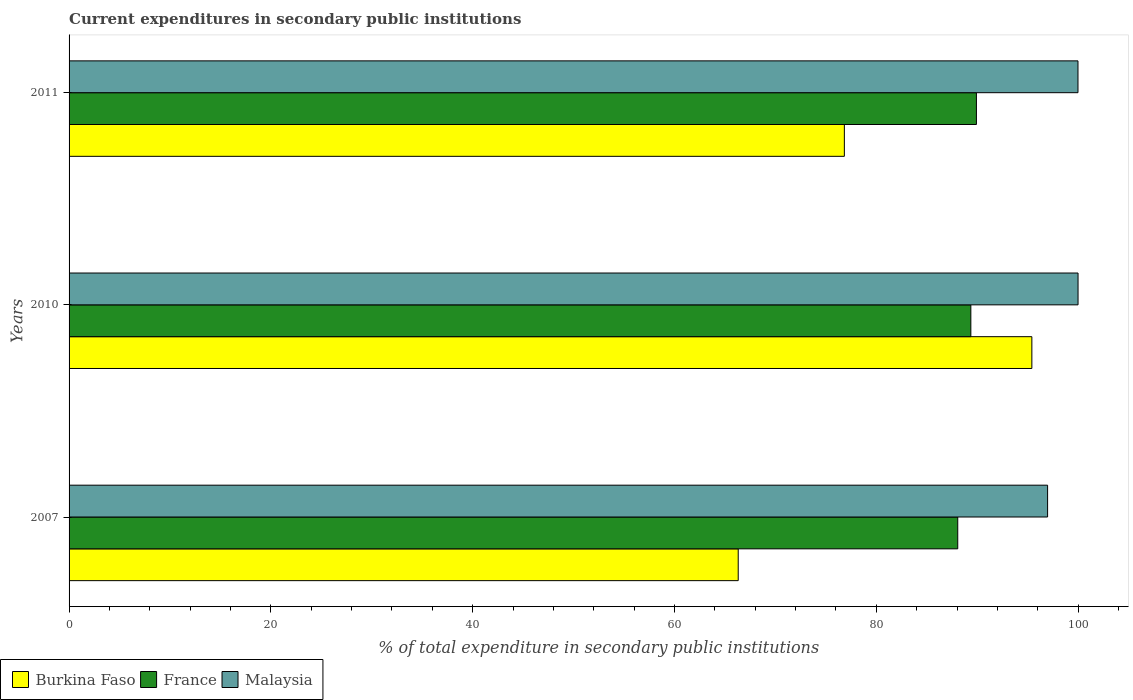How many different coloured bars are there?
Provide a succinct answer. 3. How many groups of bars are there?
Give a very brief answer. 3. What is the current expenditures in secondary public institutions in Burkina Faso in 2007?
Offer a terse response. 66.31. Across all years, what is the maximum current expenditures in secondary public institutions in Malaysia?
Provide a succinct answer. 99.99. Across all years, what is the minimum current expenditures in secondary public institutions in Malaysia?
Give a very brief answer. 96.97. What is the total current expenditures in secondary public institutions in France in the graph?
Your answer should be very brief. 267.35. What is the difference between the current expenditures in secondary public institutions in Malaysia in 2007 and that in 2011?
Offer a terse response. -3.01. What is the difference between the current expenditures in secondary public institutions in Burkina Faso in 2011 and the current expenditures in secondary public institutions in France in 2007?
Make the answer very short. -11.24. What is the average current expenditures in secondary public institutions in Burkina Faso per year?
Keep it short and to the point. 79.52. In the year 2007, what is the difference between the current expenditures in secondary public institutions in Malaysia and current expenditures in secondary public institutions in France?
Offer a very short reply. 8.9. In how many years, is the current expenditures in secondary public institutions in Burkina Faso greater than 76 %?
Give a very brief answer. 2. What is the ratio of the current expenditures in secondary public institutions in France in 2010 to that in 2011?
Offer a terse response. 0.99. Is the current expenditures in secondary public institutions in Malaysia in 2007 less than that in 2011?
Your response must be concise. Yes. What is the difference between the highest and the second highest current expenditures in secondary public institutions in France?
Provide a short and direct response. 0.55. What is the difference between the highest and the lowest current expenditures in secondary public institutions in Burkina Faso?
Provide a succinct answer. 29.1. In how many years, is the current expenditures in secondary public institutions in Burkina Faso greater than the average current expenditures in secondary public institutions in Burkina Faso taken over all years?
Your response must be concise. 1. Is the sum of the current expenditures in secondary public institutions in Malaysia in 2007 and 2010 greater than the maximum current expenditures in secondary public institutions in Burkina Faso across all years?
Your response must be concise. Yes. What does the 3rd bar from the top in 2010 represents?
Ensure brevity in your answer.  Burkina Faso. What does the 2nd bar from the bottom in 2011 represents?
Offer a very short reply. France. Are all the bars in the graph horizontal?
Make the answer very short. Yes. What is the difference between two consecutive major ticks on the X-axis?
Make the answer very short. 20. Are the values on the major ticks of X-axis written in scientific E-notation?
Your answer should be compact. No. Does the graph contain grids?
Provide a short and direct response. No. Where does the legend appear in the graph?
Your answer should be very brief. Bottom left. What is the title of the graph?
Your answer should be compact. Current expenditures in secondary public institutions. What is the label or title of the X-axis?
Give a very brief answer. % of total expenditure in secondary public institutions. What is the label or title of the Y-axis?
Your response must be concise. Years. What is the % of total expenditure in secondary public institutions of Burkina Faso in 2007?
Give a very brief answer. 66.31. What is the % of total expenditure in secondary public institutions of France in 2007?
Offer a terse response. 88.07. What is the % of total expenditure in secondary public institutions in Malaysia in 2007?
Ensure brevity in your answer.  96.97. What is the % of total expenditure in secondary public institutions of Burkina Faso in 2010?
Your answer should be compact. 95.41. What is the % of total expenditure in secondary public institutions of France in 2010?
Your answer should be compact. 89.36. What is the % of total expenditure in secondary public institutions of Malaysia in 2010?
Give a very brief answer. 99.99. What is the % of total expenditure in secondary public institutions in Burkina Faso in 2011?
Ensure brevity in your answer.  76.83. What is the % of total expenditure in secondary public institutions in France in 2011?
Provide a short and direct response. 89.92. What is the % of total expenditure in secondary public institutions of Malaysia in 2011?
Provide a succinct answer. 99.98. Across all years, what is the maximum % of total expenditure in secondary public institutions in Burkina Faso?
Ensure brevity in your answer.  95.41. Across all years, what is the maximum % of total expenditure in secondary public institutions of France?
Make the answer very short. 89.92. Across all years, what is the maximum % of total expenditure in secondary public institutions in Malaysia?
Offer a very short reply. 99.99. Across all years, what is the minimum % of total expenditure in secondary public institutions of Burkina Faso?
Provide a short and direct response. 66.31. Across all years, what is the minimum % of total expenditure in secondary public institutions of France?
Ensure brevity in your answer.  88.07. Across all years, what is the minimum % of total expenditure in secondary public institutions in Malaysia?
Offer a very short reply. 96.97. What is the total % of total expenditure in secondary public institutions in Burkina Faso in the graph?
Keep it short and to the point. 238.55. What is the total % of total expenditure in secondary public institutions in France in the graph?
Your answer should be compact. 267.35. What is the total % of total expenditure in secondary public institutions of Malaysia in the graph?
Give a very brief answer. 296.94. What is the difference between the % of total expenditure in secondary public institutions in Burkina Faso in 2007 and that in 2010?
Make the answer very short. -29.1. What is the difference between the % of total expenditure in secondary public institutions of France in 2007 and that in 2010?
Your answer should be compact. -1.3. What is the difference between the % of total expenditure in secondary public institutions in Malaysia in 2007 and that in 2010?
Your answer should be very brief. -3.02. What is the difference between the % of total expenditure in secondary public institutions in Burkina Faso in 2007 and that in 2011?
Offer a terse response. -10.52. What is the difference between the % of total expenditure in secondary public institutions of France in 2007 and that in 2011?
Ensure brevity in your answer.  -1.85. What is the difference between the % of total expenditure in secondary public institutions of Malaysia in 2007 and that in 2011?
Your answer should be very brief. -3.01. What is the difference between the % of total expenditure in secondary public institutions in Burkina Faso in 2010 and that in 2011?
Your answer should be very brief. 18.58. What is the difference between the % of total expenditure in secondary public institutions in France in 2010 and that in 2011?
Make the answer very short. -0.55. What is the difference between the % of total expenditure in secondary public institutions of Malaysia in 2010 and that in 2011?
Your answer should be compact. 0.01. What is the difference between the % of total expenditure in secondary public institutions in Burkina Faso in 2007 and the % of total expenditure in secondary public institutions in France in 2010?
Your answer should be compact. -23.05. What is the difference between the % of total expenditure in secondary public institutions in Burkina Faso in 2007 and the % of total expenditure in secondary public institutions in Malaysia in 2010?
Offer a very short reply. -33.68. What is the difference between the % of total expenditure in secondary public institutions of France in 2007 and the % of total expenditure in secondary public institutions of Malaysia in 2010?
Your response must be concise. -11.92. What is the difference between the % of total expenditure in secondary public institutions of Burkina Faso in 2007 and the % of total expenditure in secondary public institutions of France in 2011?
Keep it short and to the point. -23.61. What is the difference between the % of total expenditure in secondary public institutions of Burkina Faso in 2007 and the % of total expenditure in secondary public institutions of Malaysia in 2011?
Offer a very short reply. -33.67. What is the difference between the % of total expenditure in secondary public institutions in France in 2007 and the % of total expenditure in secondary public institutions in Malaysia in 2011?
Your response must be concise. -11.92. What is the difference between the % of total expenditure in secondary public institutions of Burkina Faso in 2010 and the % of total expenditure in secondary public institutions of France in 2011?
Provide a short and direct response. 5.49. What is the difference between the % of total expenditure in secondary public institutions in Burkina Faso in 2010 and the % of total expenditure in secondary public institutions in Malaysia in 2011?
Keep it short and to the point. -4.57. What is the difference between the % of total expenditure in secondary public institutions of France in 2010 and the % of total expenditure in secondary public institutions of Malaysia in 2011?
Your answer should be very brief. -10.62. What is the average % of total expenditure in secondary public institutions of Burkina Faso per year?
Ensure brevity in your answer.  79.52. What is the average % of total expenditure in secondary public institutions of France per year?
Keep it short and to the point. 89.12. What is the average % of total expenditure in secondary public institutions in Malaysia per year?
Offer a very short reply. 98.98. In the year 2007, what is the difference between the % of total expenditure in secondary public institutions of Burkina Faso and % of total expenditure in secondary public institutions of France?
Ensure brevity in your answer.  -21.75. In the year 2007, what is the difference between the % of total expenditure in secondary public institutions in Burkina Faso and % of total expenditure in secondary public institutions in Malaysia?
Your answer should be very brief. -30.66. In the year 2007, what is the difference between the % of total expenditure in secondary public institutions of France and % of total expenditure in secondary public institutions of Malaysia?
Provide a short and direct response. -8.9. In the year 2010, what is the difference between the % of total expenditure in secondary public institutions of Burkina Faso and % of total expenditure in secondary public institutions of France?
Make the answer very short. 6.05. In the year 2010, what is the difference between the % of total expenditure in secondary public institutions in Burkina Faso and % of total expenditure in secondary public institutions in Malaysia?
Make the answer very short. -4.58. In the year 2010, what is the difference between the % of total expenditure in secondary public institutions of France and % of total expenditure in secondary public institutions of Malaysia?
Your response must be concise. -10.62. In the year 2011, what is the difference between the % of total expenditure in secondary public institutions in Burkina Faso and % of total expenditure in secondary public institutions in France?
Offer a terse response. -13.09. In the year 2011, what is the difference between the % of total expenditure in secondary public institutions of Burkina Faso and % of total expenditure in secondary public institutions of Malaysia?
Ensure brevity in your answer.  -23.15. In the year 2011, what is the difference between the % of total expenditure in secondary public institutions of France and % of total expenditure in secondary public institutions of Malaysia?
Ensure brevity in your answer.  -10.06. What is the ratio of the % of total expenditure in secondary public institutions of Burkina Faso in 2007 to that in 2010?
Give a very brief answer. 0.69. What is the ratio of the % of total expenditure in secondary public institutions of France in 2007 to that in 2010?
Offer a terse response. 0.99. What is the ratio of the % of total expenditure in secondary public institutions of Malaysia in 2007 to that in 2010?
Provide a short and direct response. 0.97. What is the ratio of the % of total expenditure in secondary public institutions in Burkina Faso in 2007 to that in 2011?
Give a very brief answer. 0.86. What is the ratio of the % of total expenditure in secondary public institutions of France in 2007 to that in 2011?
Your answer should be very brief. 0.98. What is the ratio of the % of total expenditure in secondary public institutions in Malaysia in 2007 to that in 2011?
Offer a terse response. 0.97. What is the ratio of the % of total expenditure in secondary public institutions of Burkina Faso in 2010 to that in 2011?
Offer a very short reply. 1.24. What is the difference between the highest and the second highest % of total expenditure in secondary public institutions in Burkina Faso?
Provide a short and direct response. 18.58. What is the difference between the highest and the second highest % of total expenditure in secondary public institutions of France?
Your answer should be very brief. 0.55. What is the difference between the highest and the second highest % of total expenditure in secondary public institutions of Malaysia?
Offer a very short reply. 0.01. What is the difference between the highest and the lowest % of total expenditure in secondary public institutions of Burkina Faso?
Your answer should be very brief. 29.1. What is the difference between the highest and the lowest % of total expenditure in secondary public institutions in France?
Ensure brevity in your answer.  1.85. What is the difference between the highest and the lowest % of total expenditure in secondary public institutions in Malaysia?
Offer a terse response. 3.02. 